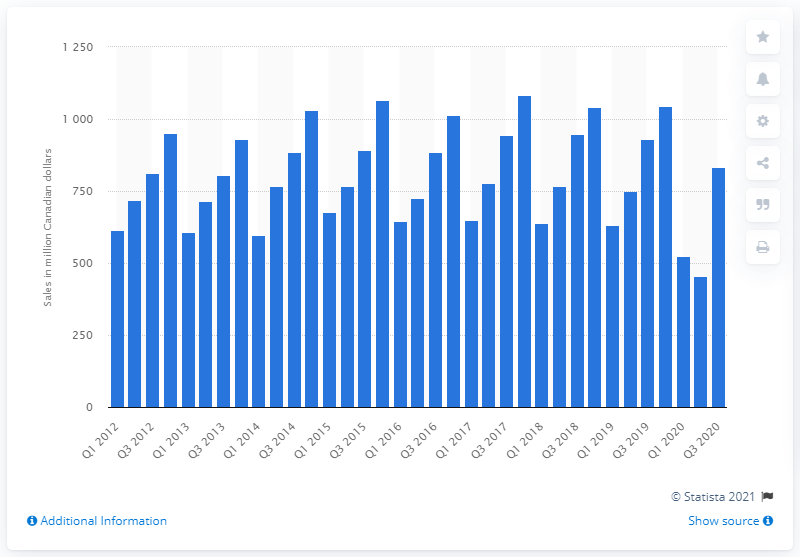Point out several critical features in this image. In the first quarter of 2020, the retail sales of children's and infants' clothing and accessories in Canada reached CAD 525.87 million. 